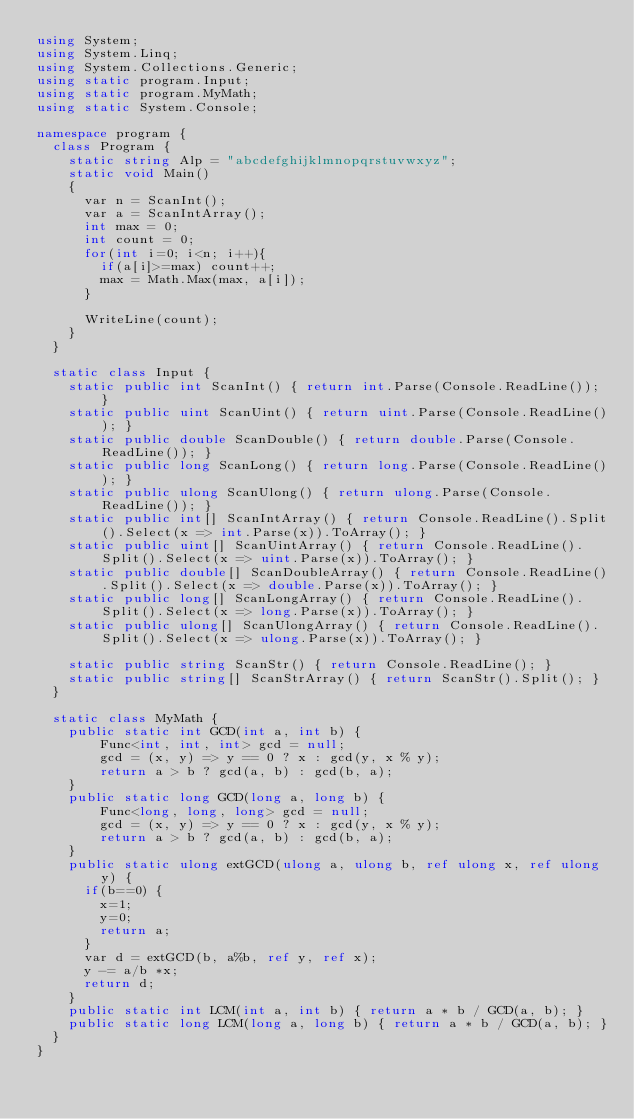Convert code to text. <code><loc_0><loc_0><loc_500><loc_500><_C#_>using System;
using System.Linq;
using System.Collections.Generic;
using static program.Input;
using static program.MyMath;
using static System.Console;

namespace program {
  class Program {
    static string Alp = "abcdefghijklmnopqrstuvwxyz";
    static void Main()
    {
      var n = ScanInt();
      var a = ScanIntArray();
      int max = 0;
      int count = 0;
      for(int i=0; i<n; i++){
        if(a[i]>=max) count++;
        max = Math.Max(max, a[i]);
      }
      
      WriteLine(count);
    }
  }
  
  static class Input {
    static public int ScanInt() { return int.Parse(Console.ReadLine()); }
    static public uint ScanUint() { return uint.Parse(Console.ReadLine()); }
    static public double ScanDouble() { return double.Parse(Console.ReadLine()); }
    static public long ScanLong() { return long.Parse(Console.ReadLine()); }
    static public ulong ScanUlong() { return ulong.Parse(Console.ReadLine()); }
    static public int[] ScanIntArray() { return Console.ReadLine().Split().Select(x => int.Parse(x)).ToArray(); }
    static public uint[] ScanUintArray() { return Console.ReadLine().Split().Select(x => uint.Parse(x)).ToArray(); }
    static public double[] ScanDoubleArray() { return Console.ReadLine().Split().Select(x => double.Parse(x)).ToArray(); }
    static public long[] ScanLongArray() { return Console.ReadLine().Split().Select(x => long.Parse(x)).ToArray(); }
    static public ulong[] ScanUlongArray() { return Console.ReadLine().Split().Select(x => ulong.Parse(x)).ToArray(); }

    static public string ScanStr() { return Console.ReadLine(); }
    static public string[] ScanStrArray() { return ScanStr().Split(); }
  }
  
  static class MyMath {
    public static int GCD(int a, int b) {
        Func<int, int, int> gcd = null;
        gcd = (x, y) => y == 0 ? x : gcd(y, x % y);
        return a > b ? gcd(a, b) : gcd(b, a);
    }
    public static long GCD(long a, long b) {
        Func<long, long, long> gcd = null;
        gcd = (x, y) => y == 0 ? x : gcd(y, x % y);
        return a > b ? gcd(a, b) : gcd(b, a);
    }
    public static ulong extGCD(ulong a, ulong b, ref ulong x, ref ulong y) {
      if(b==0) {
        x=1; 
        y=0;
        return a;
      }
      var d = extGCD(b, a%b, ref y, ref x);
      y -= a/b *x;
      return d;
    }
    public static int LCM(int a, int b) { return a * b / GCD(a, b); }
    public static long LCM(long a, long b) { return a * b / GCD(a, b); }
  }
}
</code> 